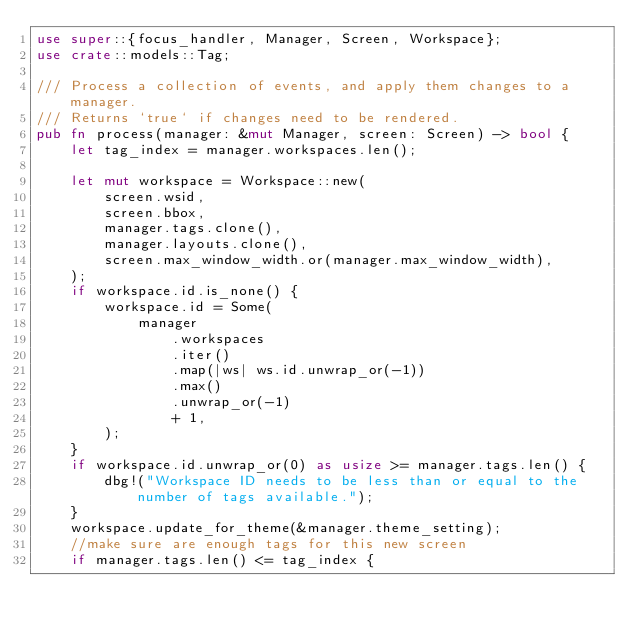Convert code to text. <code><loc_0><loc_0><loc_500><loc_500><_Rust_>use super::{focus_handler, Manager, Screen, Workspace};
use crate::models::Tag;

/// Process a collection of events, and apply them changes to a manager.
/// Returns `true` if changes need to be rendered.
pub fn process(manager: &mut Manager, screen: Screen) -> bool {
    let tag_index = manager.workspaces.len();

    let mut workspace = Workspace::new(
        screen.wsid,
        screen.bbox,
        manager.tags.clone(),
        manager.layouts.clone(),
        screen.max_window_width.or(manager.max_window_width),
    );
    if workspace.id.is_none() {
        workspace.id = Some(
            manager
                .workspaces
                .iter()
                .map(|ws| ws.id.unwrap_or(-1))
                .max()
                .unwrap_or(-1)
                + 1,
        );
    }
    if workspace.id.unwrap_or(0) as usize >= manager.tags.len() {
        dbg!("Workspace ID needs to be less than or equal to the number of tags available.");
    }
    workspace.update_for_theme(&manager.theme_setting);
    //make sure are enough tags for this new screen
    if manager.tags.len() <= tag_index {</code> 